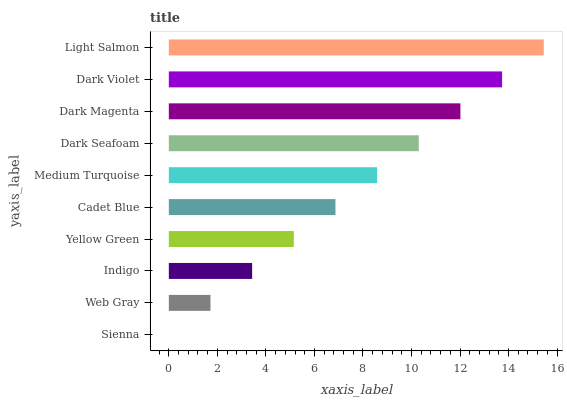Is Sienna the minimum?
Answer yes or no. Yes. Is Light Salmon the maximum?
Answer yes or no. Yes. Is Web Gray the minimum?
Answer yes or no. No. Is Web Gray the maximum?
Answer yes or no. No. Is Web Gray greater than Sienna?
Answer yes or no. Yes. Is Sienna less than Web Gray?
Answer yes or no. Yes. Is Sienna greater than Web Gray?
Answer yes or no. No. Is Web Gray less than Sienna?
Answer yes or no. No. Is Medium Turquoise the high median?
Answer yes or no. Yes. Is Cadet Blue the low median?
Answer yes or no. Yes. Is Yellow Green the high median?
Answer yes or no. No. Is Medium Turquoise the low median?
Answer yes or no. No. 